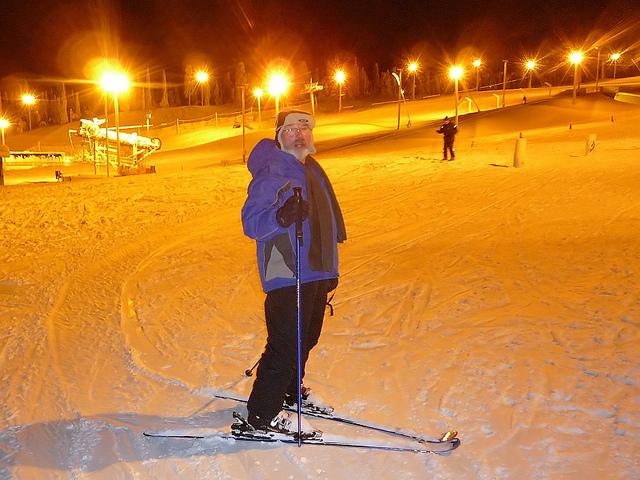How many people are in this picture?
Short answer required. 2. Is the man skiing alone?
Write a very short answer. Yes. What is on the skiers hands?
Short answer required. Gloves. What are the marks in the snow?
Be succinct. Ski tracks. 